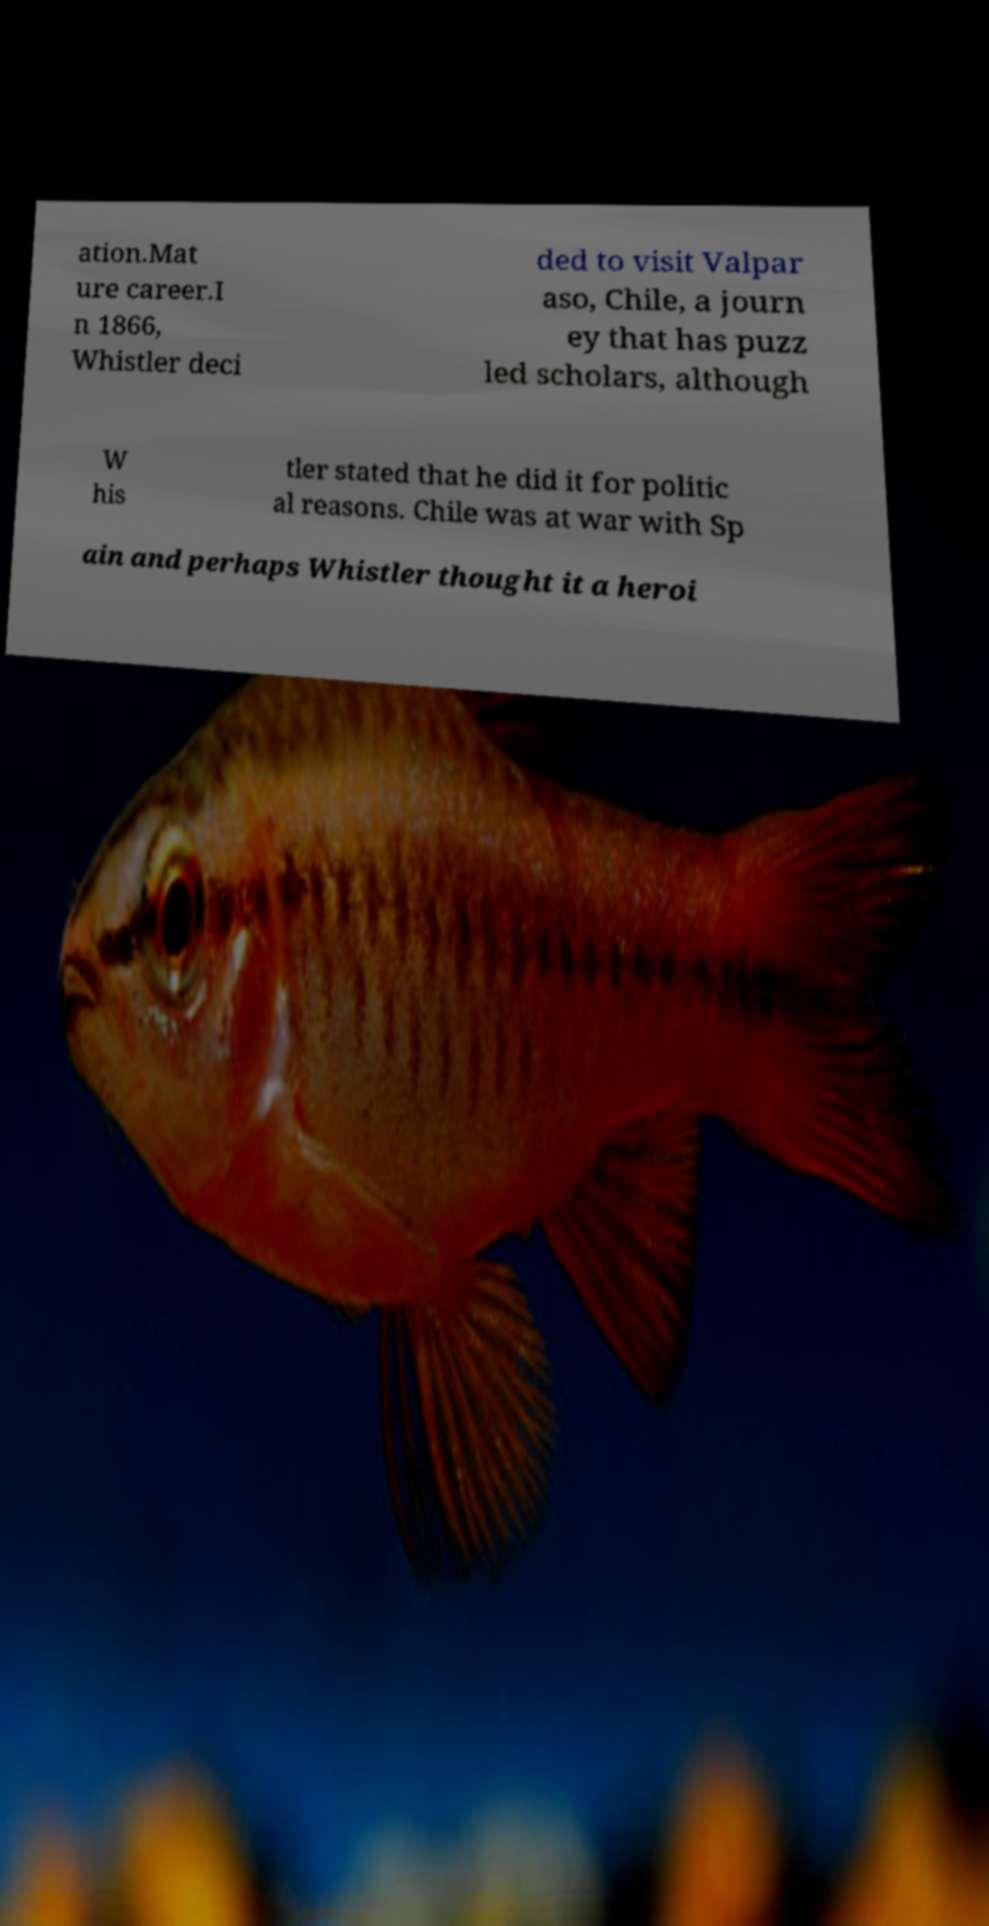Could you assist in decoding the text presented in this image and type it out clearly? ation.Mat ure career.I n 1866, Whistler deci ded to visit Valpar aso, Chile, a journ ey that has puzz led scholars, although W his tler stated that he did it for politic al reasons. Chile was at war with Sp ain and perhaps Whistler thought it a heroi 